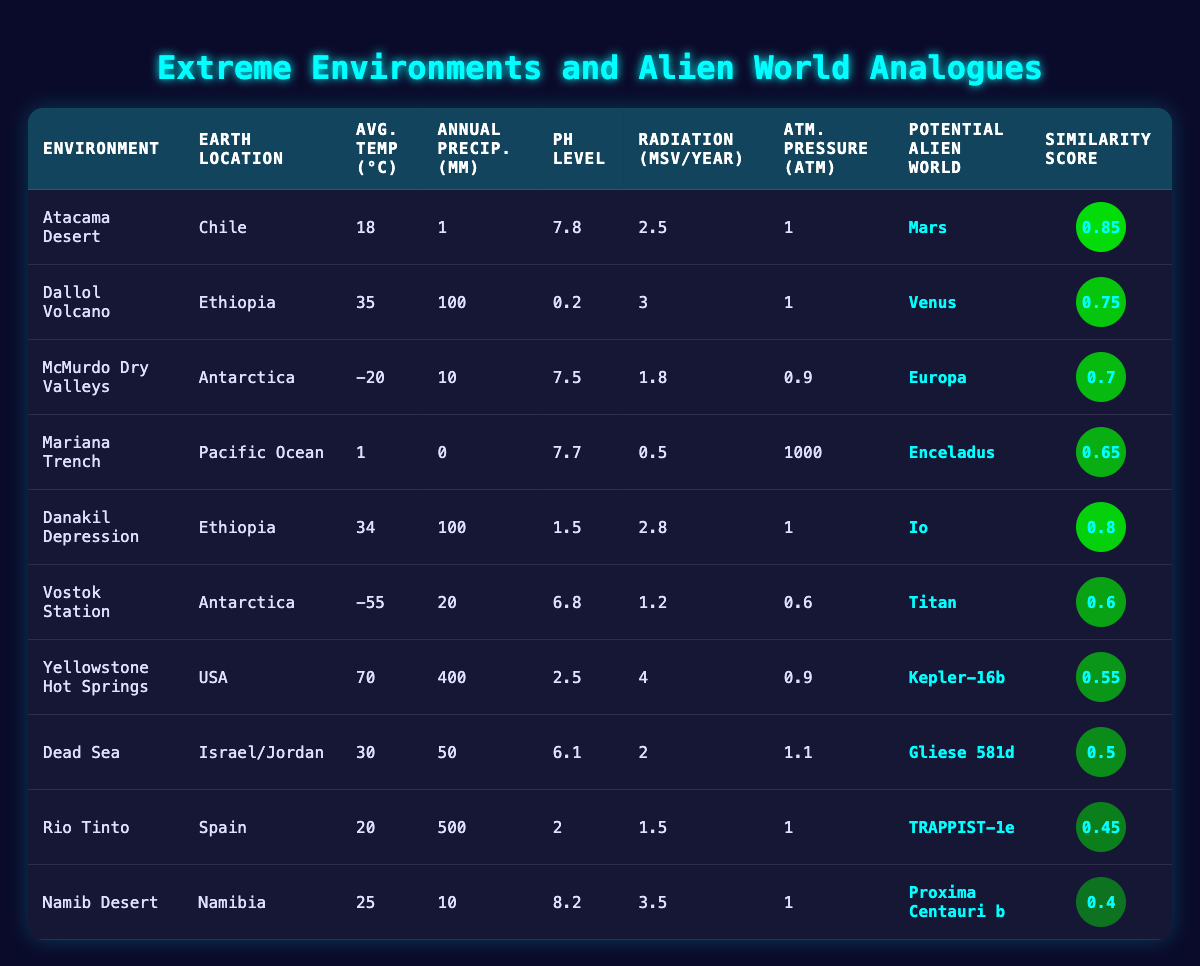What is the pH level of the Atacama Desert? The table indicates that the pH level of the Atacama Desert is listed under the "pH Level" column, which shows a value of 7.8.
Answer: 7.8 Which environment has the highest average temperature? By comparing the "Average Temperature (°C)" column, Dallol Volcano has the highest value at 35°C, followed by the Danakil Depression at 34°C.
Answer: Dallol Volcano Is the similarity score of the Mariana Trench greater than 0.6? The similarity score for the Mariana Trench is 0.65, which is indeed greater than 0.6.
Answer: Yes What is the average annual precipitation of the environments located in Antarctica? The two environments in Antarctica are McMurdo Dry Valleys with 10 mm and Vostok Station with 20 mm. The average is (10 + 20) / 2 = 15 mm.
Answer: 15 mm How many environments have a similarity score greater than or equal to 0.7? The environments with a similarity score of 0.7 or higher are Atacama Desert (0.85), Dallol Volcano (0.75), Danakil Depression (0.80), and McMurdo Dry Valleys (0.70), totaling 4 environments.
Answer: 4 What is the difference in average temperature between the Dead Sea and the Rio Tinto? The average temperature for the Dead Sea is 30°C and for the Rio Tinto it's 20°C. The difference is 30 - 20 = 10°C.
Answer: 10°C Does the Danakil Depression have less annual precipitation than the Yellowstone Hot Springs? The Danakil Depression has 100 mm of annual precipitation while the Yellowstone Hot Springs has 400 mm, confirming that Danakil Depression has less precipitation.
Answer: Yes Which potential alien world has the lowest similarity score? By checking the "Similarity Score" column, Proxima Centauri b holds the lowest score at 0.4 among the listed environments.
Answer: Proxima Centauri b What is the total radiation exposure for environments located in Ethiopia? The environments in Ethiopia are Dallol Volcano with 3 mSv/year and Danakil Depression with 2.8 mSv/year. The total radiation exposure is 3 + 2.8 = 5.8 mSv/year.
Answer: 5.8 mSv/year 